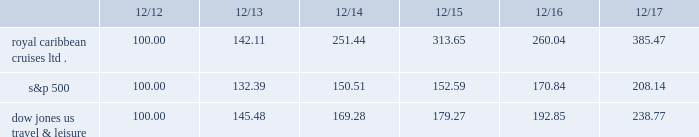Performance graph the following graph compares the total return , assuming reinvestment of dividends , on an investment in the company , based on performance of the company's common stock , with the total return of the standard & poor's 500 composite stock index and the dow jones united states travel and leisure index for a five year period by measuring the changes in common stock prices from december 31 , 2012 to december 31 , 2017. .
The stock performance graph assumes for comparison that the value of the company's common stock and of each index was $ 100 on december 31 , 2012 and that all dividends were reinvested .
Past performance is not necessarily an indicator of future results. .
What is the mathematical mean for all three investments as of dec 31 , 2017? 
Rationale: average
Computations: (((385.47 + 208.14) + 238.77) / 3)
Answer: 277.46. Performance graph the following graph compares the total return , assuming reinvestment of dividends , on an investment in the company , based on performance of the company's common stock , with the total return of the standard & poor's 500 composite stock index and the dow jones united states travel and leisure index for a five year period by measuring the changes in common stock prices from december 31 , 2012 to december 31 , 2017. .
The stock performance graph assumes for comparison that the value of the company's common stock and of each index was $ 100 on december 31 , 2012 and that all dividends were reinvested .
Past performance is not necessarily an indicator of future results. .
What is the mathematical mean for all three investments as of dec 31 , 2017? 
Rationale: average
Computations: (((385.47 + 208.14) + 238.77) / 3)
Answer: 277.46. 